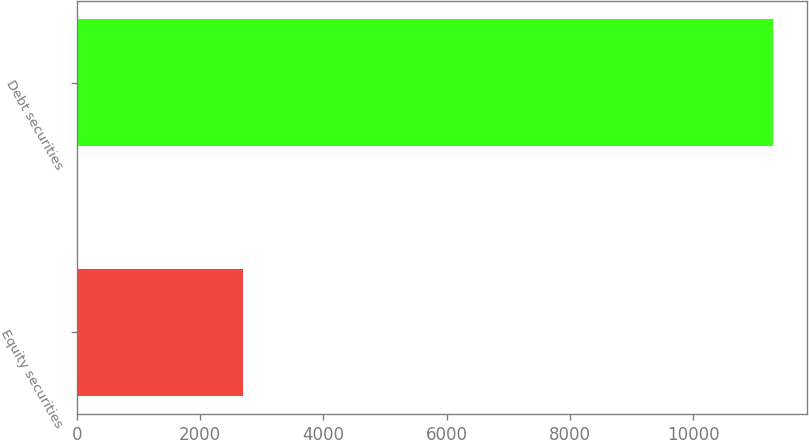Convert chart. <chart><loc_0><loc_0><loc_500><loc_500><bar_chart><fcel>Equity securities<fcel>Debt securities<nl><fcel>2701<fcel>11287<nl></chart> 